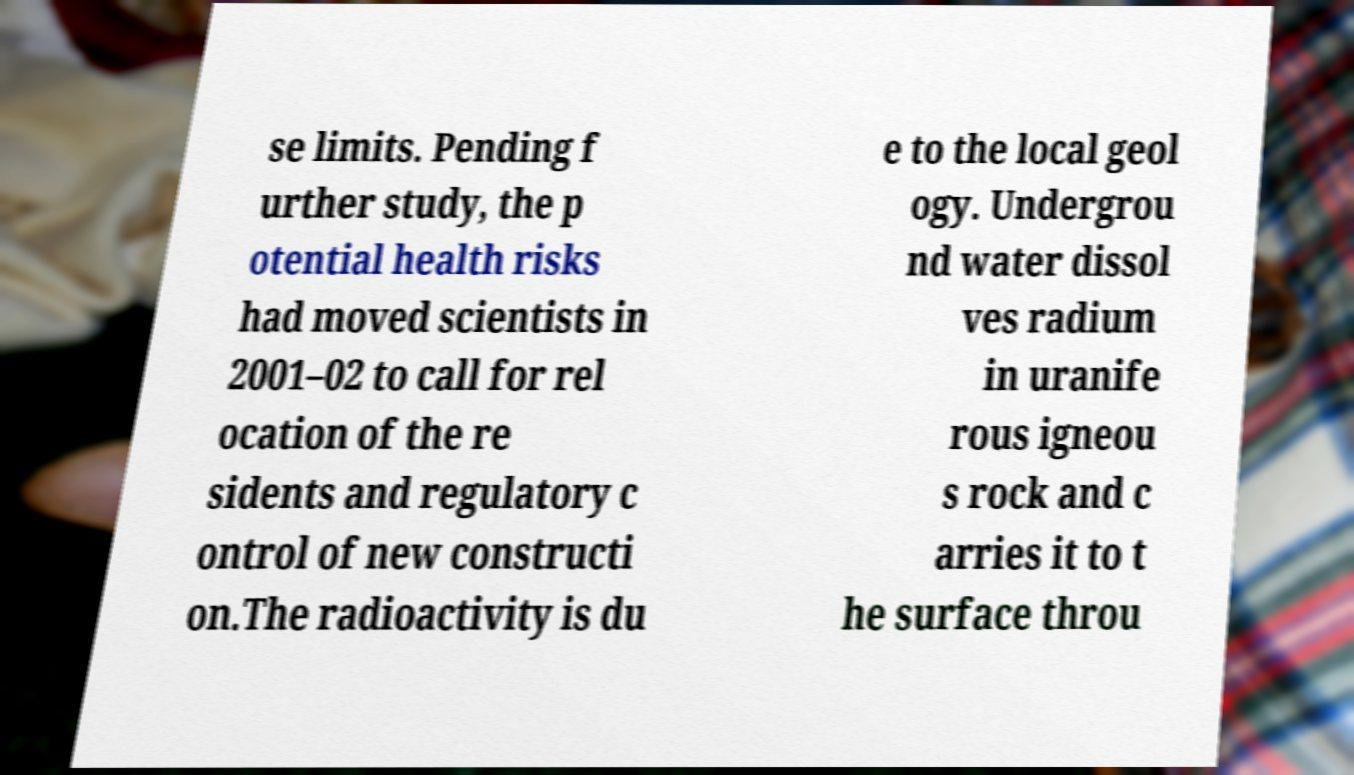Can you read and provide the text displayed in the image?This photo seems to have some interesting text. Can you extract and type it out for me? se limits. Pending f urther study, the p otential health risks had moved scientists in 2001–02 to call for rel ocation of the re sidents and regulatory c ontrol of new constructi on.The radioactivity is du e to the local geol ogy. Undergrou nd water dissol ves radium in uranife rous igneou s rock and c arries it to t he surface throu 